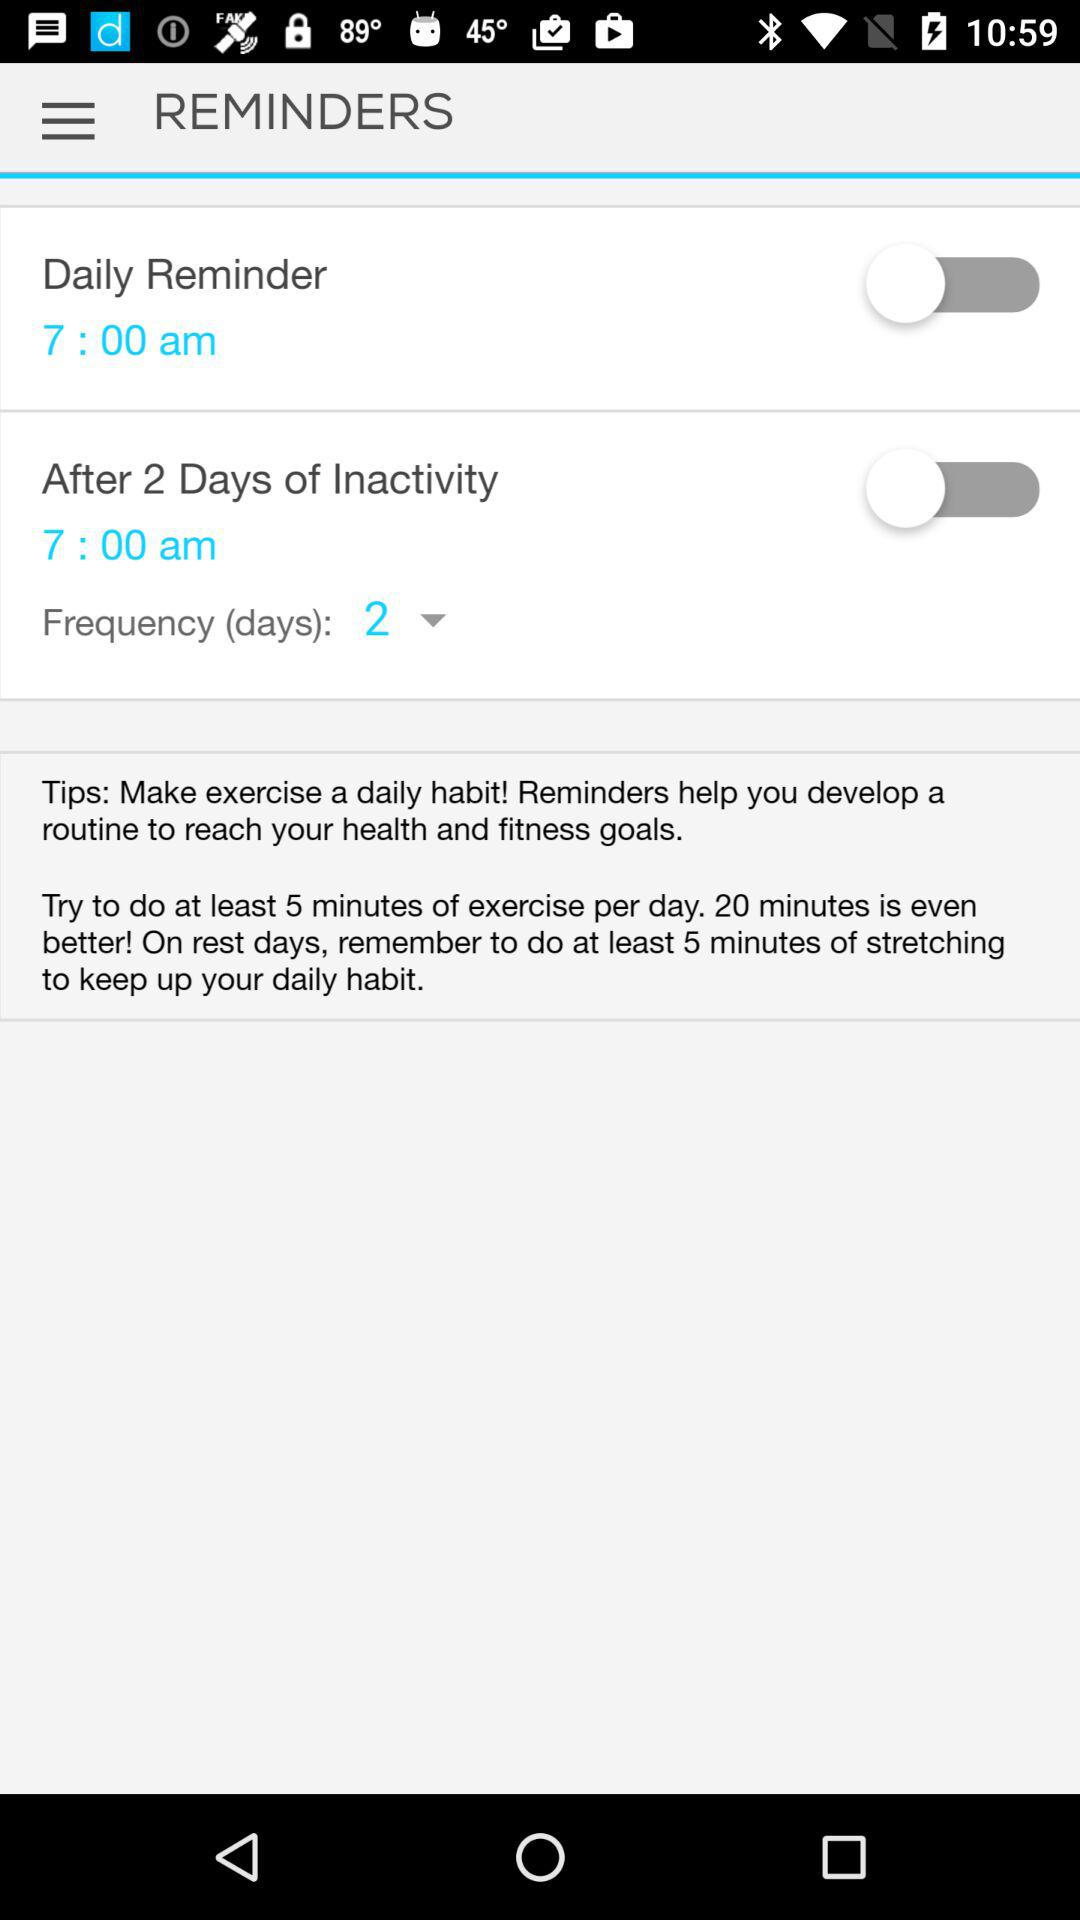What time is set for the daily reminder? The set time is 7:00 a.m. 